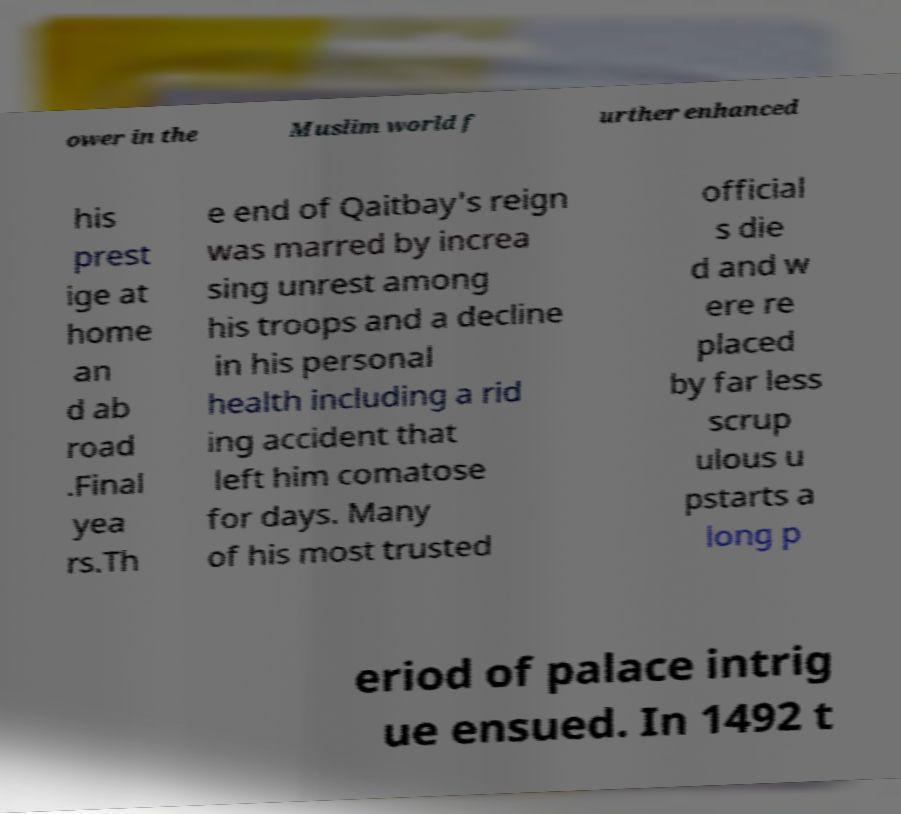What messages or text are displayed in this image? I need them in a readable, typed format. ower in the Muslim world f urther enhanced his prest ige at home an d ab road .Final yea rs.Th e end of Qaitbay's reign was marred by increa sing unrest among his troops and a decline in his personal health including a rid ing accident that left him comatose for days. Many of his most trusted official s die d and w ere re placed by far less scrup ulous u pstarts a long p eriod of palace intrig ue ensued. In 1492 t 